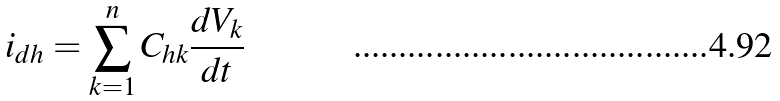Convert formula to latex. <formula><loc_0><loc_0><loc_500><loc_500>i _ { d h } = \sum _ { k = 1 } ^ { n } C _ { h k } \frac { d V _ { k } } { d t }</formula> 